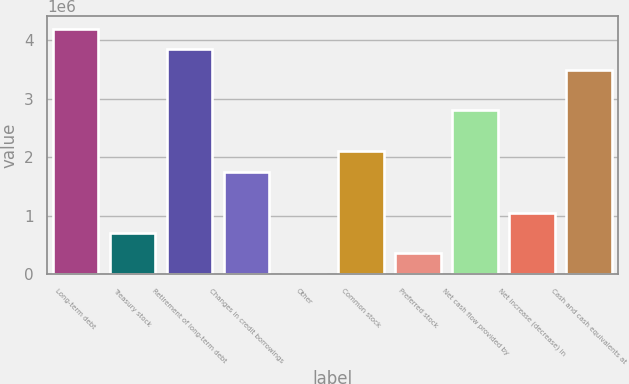Convert chart. <chart><loc_0><loc_0><loc_500><loc_500><bar_chart><fcel>Long-term debt<fcel>Treasury stock<fcel>Retirement of long-term debt<fcel>Changes in credit borrowings<fcel>Other<fcel>Common stock<fcel>Preferred stock<fcel>Net cash flow provided by<fcel>Net increase (decrease) in<fcel>Cash and cash equivalents at<nl><fcel>4.2008e+06<fcel>707747<fcel>3.85149e+06<fcel>1.75566e+06<fcel>9136<fcel>2.10497e+06<fcel>358441<fcel>2.80358e+06<fcel>1.05705e+06<fcel>3.50219e+06<nl></chart> 